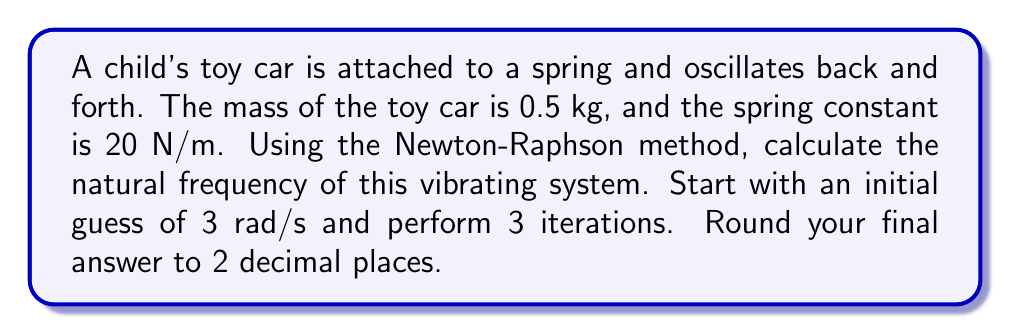Solve this math problem. To solve this problem, we'll use the Newton-Raphson method to find the natural frequency of the vibrating system. The equation for natural frequency is:

$$\omega_n = \sqrt{\frac{k}{m}}$$

where $\omega_n$ is the natural frequency in rad/s, $k$ is the spring constant in N/m, and $m$ is the mass in kg.

Step 1: Define the function $f(\omega)$ and its derivative $f'(\omega)$:
$$f(\omega) = \omega^2 - \frac{k}{m} = \omega^2 - \frac{20}{0.5} = \omega^2 - 40$$
$$f'(\omega) = 2\omega$$

Step 2: Apply the Newton-Raphson formula for 3 iterations:
$$\omega_{n+1} = \omega_n - \frac{f(\omega_n)}{f'(\omega_n)}$$

Iteration 1:
$$\omega_1 = 3 - \frac{3^2 - 40}{2(3)} = 3 - \frac{-31}{6} = 8.1667$$

Iteration 2:
$$\omega_2 = 8.1667 - \frac{8.1667^2 - 40}{2(8.1667)} = 8.1667 - \frac{26.6945}{16.3334} = 6.5326$$

Iteration 3:
$$\omega_3 = 6.5326 - \frac{6.5326^2 - 40}{2(6.5326)} = 6.5326 - \frac{2.6752}{13.0652} = 6.3278$$

Step 3: Round the final result to 2 decimal places:
$$\omega_n \approx 6.33 \text{ rad/s}$$
Answer: 6.33 rad/s 